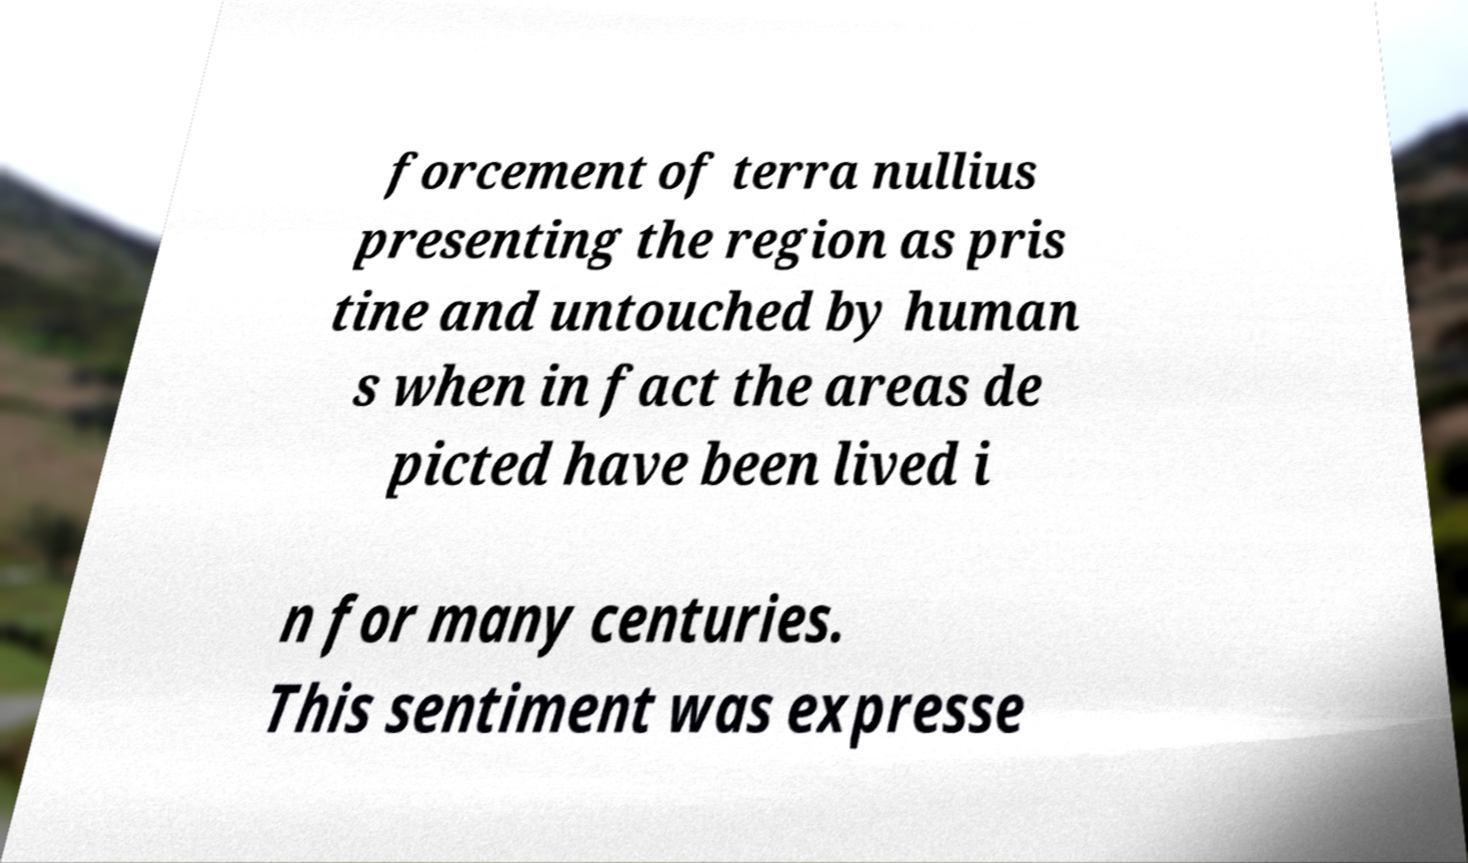There's text embedded in this image that I need extracted. Can you transcribe it verbatim? forcement of terra nullius presenting the region as pris tine and untouched by human s when in fact the areas de picted have been lived i n for many centuries. This sentiment was expresse 